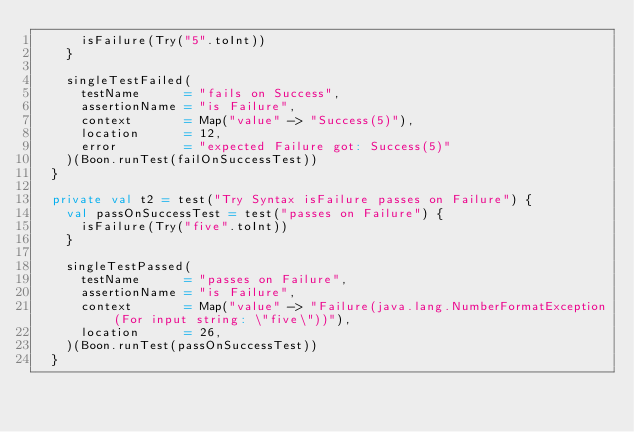<code> <loc_0><loc_0><loc_500><loc_500><_Scala_>      isFailure(Try("5".toInt))
    }

    singleTestFailed(
      testName      = "fails on Success",
      assertionName = "is Failure",
      context       = Map("value" -> "Success(5)"),
      location      = 12,
      error         = "expected Failure got: Success(5)"
    )(Boon.runTest(failOnSuccessTest))
  }

  private val t2 = test("Try Syntax isFailure passes on Failure") {
    val passOnSuccessTest = test("passes on Failure") {
      isFailure(Try("five".toInt))
    }

    singleTestPassed(
      testName      = "passes on Failure",
      assertionName = "is Failure",
      context       = Map("value" -> "Failure(java.lang.NumberFormatException(For input string: \"five\"))"),
      location      = 26,
    )(Boon.runTest(passOnSuccessTest))
  }
</code> 